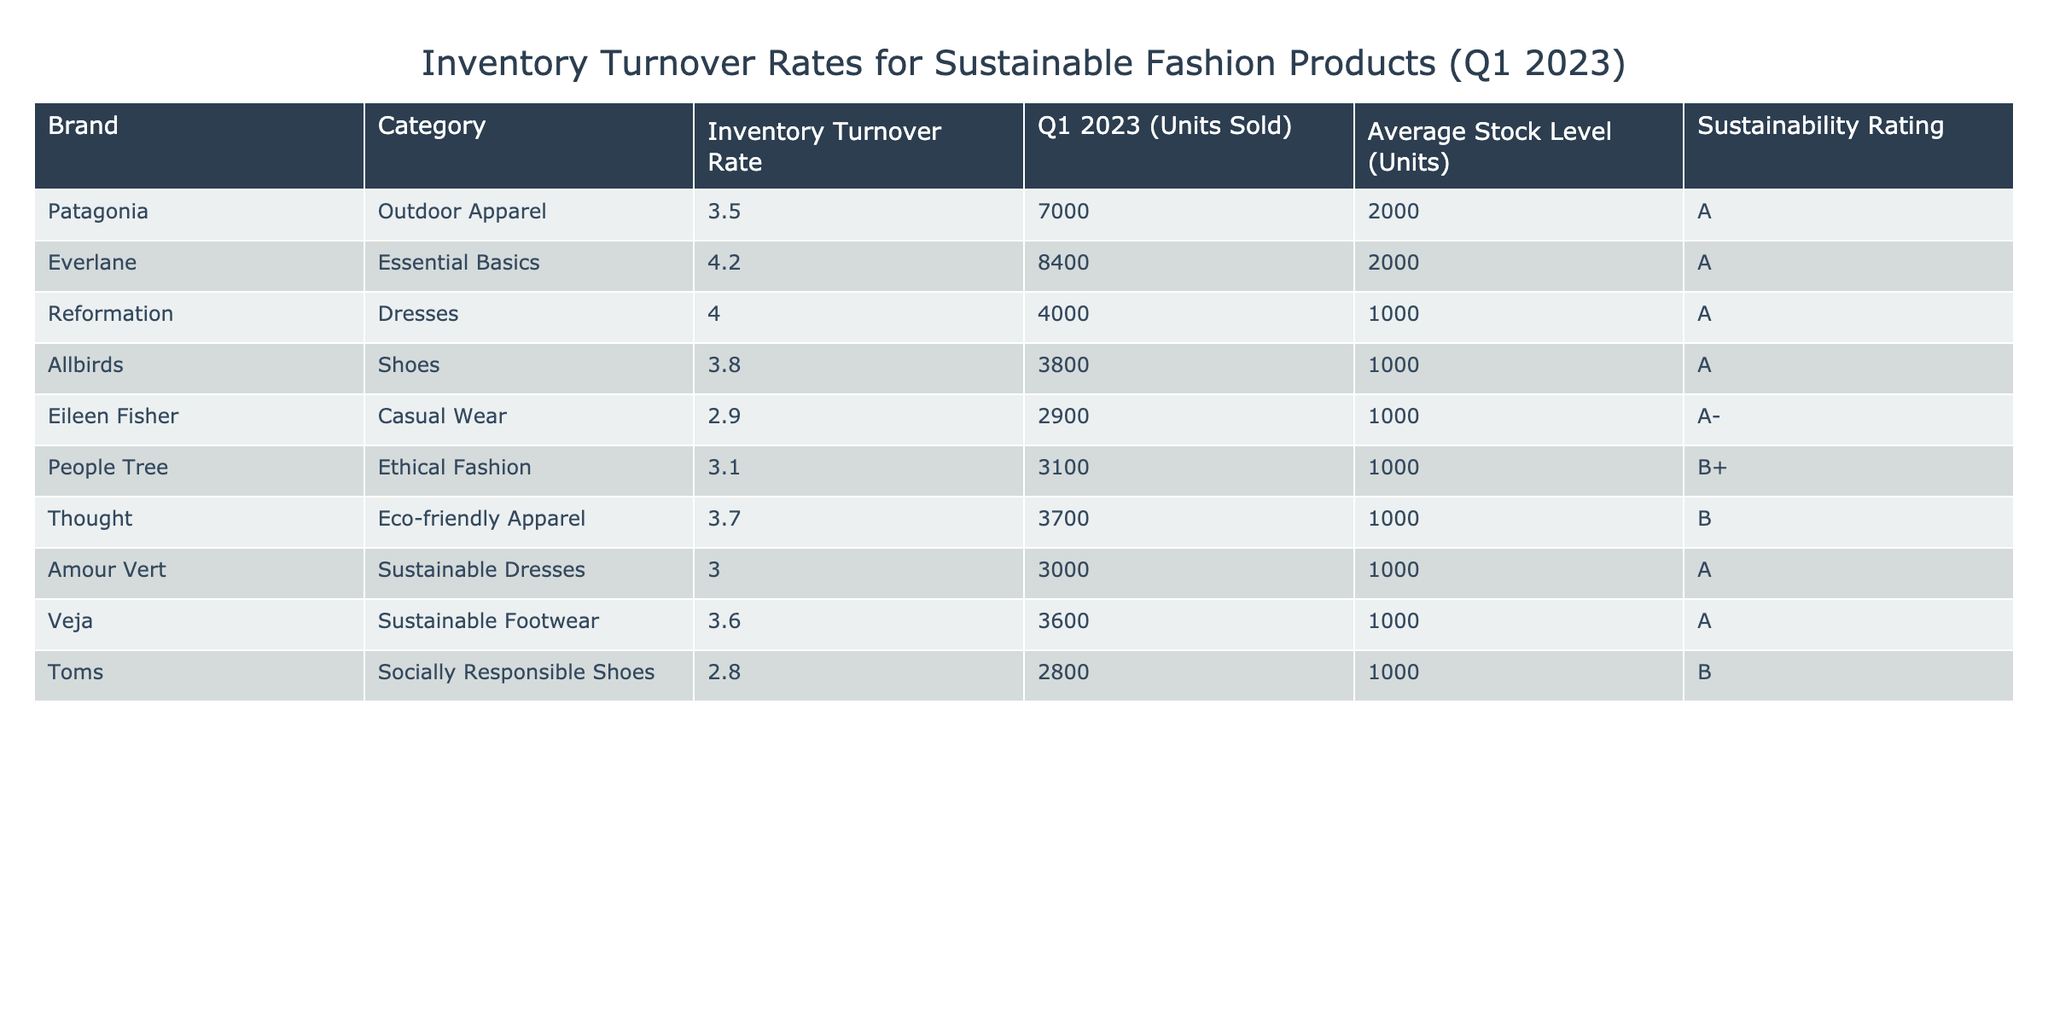What is the inventory turnover rate for Everlane? The table shows that the inventory turnover rate for Everlane is 4.2.
Answer: 4.2 Which brand has the highest inventory turnover rate? By reviewing the turnovers, Everlane has the highest rate at 4.2.
Answer: Everlane What is the sustainability rating of People Tree? The table indicates that People Tree has a sustainability rating of B+.
Answer: B+ How many units did Patagonia sell in Q1 2023? The table lists that Patagonia sold 7000 units in Q1 2023.
Answer: 7000 What is the average inventory turnover rate for brands rated A? The brands with an A rating are Patagonia, Everlane, Reformation, Allbirds, Veja, and Amour Vert. Their turnover rates are 3.5, 4.2, 4.0, 3.8, 3.6, and 3.0 respectively. The average is (3.5 + 4.2 + 4.0 + 3.8 + 3.6 + 3.0) / 6 = 3.63.
Answer: 3.63 Which category sold the least number of units in Q1 2023? Upon observation, Toms in the Socially Responsible Shoes category sold the least with 2800 units.
Answer: Toms Are there any brands with an inventory turnover rate below 3.0? Yes, Toms has an inventory turnover rate of 2.8 and Eileen Fisher has 2.9, both below 3.0.
Answer: Yes Which brand has the lowest average stock level? All listed brands have an average stock level of 1000 units, except for Patagonia and Everlane which have 2000 units. Hence, they all share the lowest stock level of 1000 units.
Answer: All brands except Patagonia and Everlane share the lowest average stock level What is the difference in units sold between the highest and lowest selling products? The highest selling product is Everlane with 8400 units, and the lowest is Toms with 2800 units. The difference is 8400 - 2800 = 5600 units.
Answer: 5600 If we sum the inventory turnover rates of all brands, what is the total? Adding the turnover rates of all listed brands: 3.5 + 4.2 + 4.0 + 3.8 + 2.9 + 3.1 + 3.7 + 3.0 + 3.6 + 2.8 = 34.6.
Answer: 34.6 